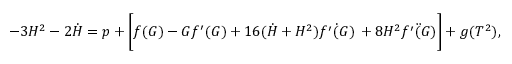<formula> <loc_0><loc_0><loc_500><loc_500>- 3 H ^ { 2 } - 2 \dot { H } = p + \left [ f ( G ) - G f ^ { \prime } ( G ) + 1 6 ( \dot { H } + H ^ { 2 } ) \dot { f ^ { \prime } ( G ) } \, + 8 H ^ { 2 } \ddot { f ^ { \prime } ( G ) } \right ] + g ( T ^ { 2 } ) ,</formula> 